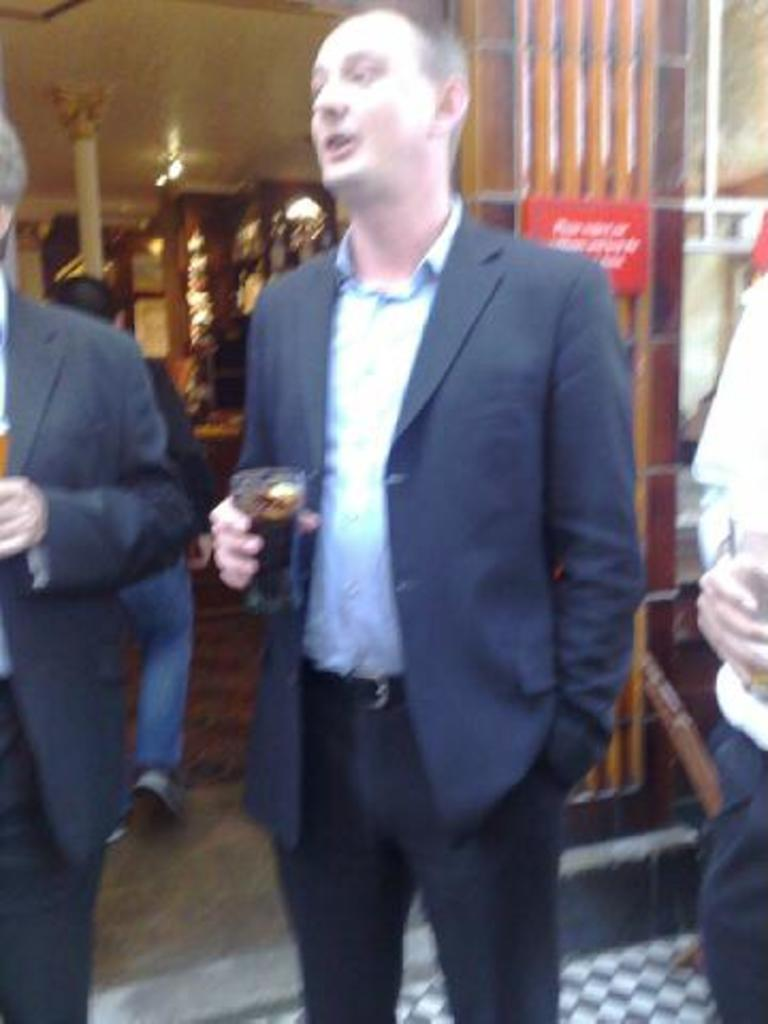What is the man in the image holding? The man is holding a glass in the image. Who else is present in the image besides the man? There are two persons standing on either side of the man. What can be seen in the background of the image? There are lights visible in the background of the image. What type of cork can be seen floating in the ocean in the image? There is no ocean or cork present in the image; it features a man holding a glass with two other persons standing nearby, and lights in the background. 